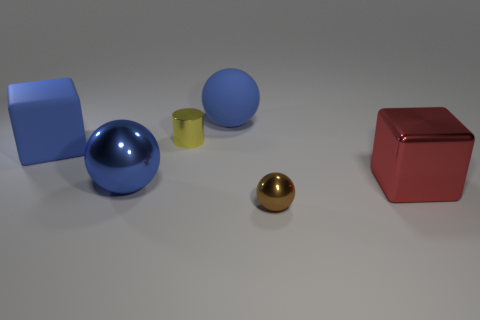Subtract all shiny balls. How many balls are left? 1 Add 4 large brown shiny cylinders. How many objects exist? 10 Subtract all cylinders. How many objects are left? 5 Subtract 0 cyan blocks. How many objects are left? 6 Subtract all tiny yellow metallic objects. Subtract all tiny yellow metallic cylinders. How many objects are left? 4 Add 1 large red metal things. How many large red metal things are left? 2 Add 3 small gray shiny things. How many small gray shiny things exist? 3 